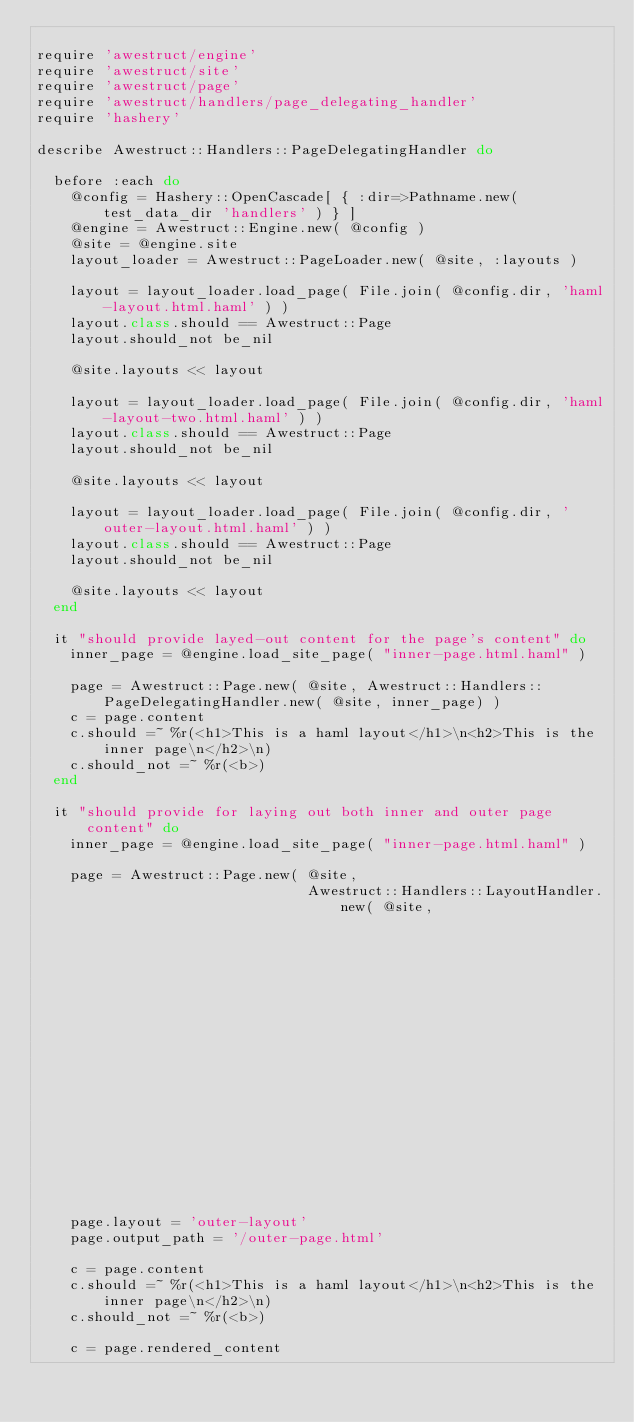<code> <loc_0><loc_0><loc_500><loc_500><_Ruby_>
require 'awestruct/engine'
require 'awestruct/site'
require 'awestruct/page'
require 'awestruct/handlers/page_delegating_handler'
require 'hashery'

describe Awestruct::Handlers::PageDelegatingHandler do

  before :each do
    @config = Hashery::OpenCascade[ { :dir=>Pathname.new( test_data_dir 'handlers' ) } ]
    @engine = Awestruct::Engine.new( @config )
    @site = @engine.site
    layout_loader = Awestruct::PageLoader.new( @site, :layouts )

    layout = layout_loader.load_page( File.join( @config.dir, 'haml-layout.html.haml' ) )
    layout.class.should == Awestruct::Page
    layout.should_not be_nil

    @site.layouts << layout

    layout = layout_loader.load_page( File.join( @config.dir, 'haml-layout-two.html.haml' ) )
    layout.class.should == Awestruct::Page
    layout.should_not be_nil

    @site.layouts << layout

    layout = layout_loader.load_page( File.join( @config.dir, 'outer-layout.html.haml' ) )
    layout.class.should == Awestruct::Page
    layout.should_not be_nil

    @site.layouts << layout
  end

  it "should provide layed-out content for the page's content" do
    inner_page = @engine.load_site_page( "inner-page.html.haml" )

    page = Awestruct::Page.new( @site, Awestruct::Handlers::PageDelegatingHandler.new( @site, inner_page) )
    c = page.content
    c.should =~ %r(<h1>This is a haml layout</h1>\n<h2>This is the inner page\n</h2>\n)
    c.should_not =~ %r(<b>)
  end

  it "should provide for laying out both inner and outer page content" do
    inner_page = @engine.load_site_page( "inner-page.html.haml" )

    page = Awestruct::Page.new( @site,
                                Awestruct::Handlers::LayoutHandler.new( @site,
                                                                        Awestruct::Handlers::PageDelegatingHandler.new( @site,
                                                                                                                        inner_page) ) )
    page.layout = 'outer-layout'
    page.output_path = '/outer-page.html'

    c = page.content
    c.should =~ %r(<h1>This is a haml layout</h1>\n<h2>This is the inner page\n</h2>\n)
    c.should_not =~ %r(<b>)

    c = page.rendered_content</code> 